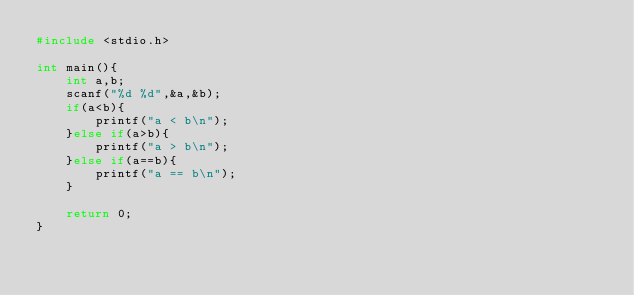Convert code to text. <code><loc_0><loc_0><loc_500><loc_500><_C_>#include <stdio.h>

int main(){
	int a,b;
	scanf("%d %d",&a,&b);
	if(a<b){
		printf("a < b\n");
	}else if(a>b){
		printf("a > b\n");
	}else if(a==b){
		printf("a == b\n");
	}

	return 0;
}</code> 